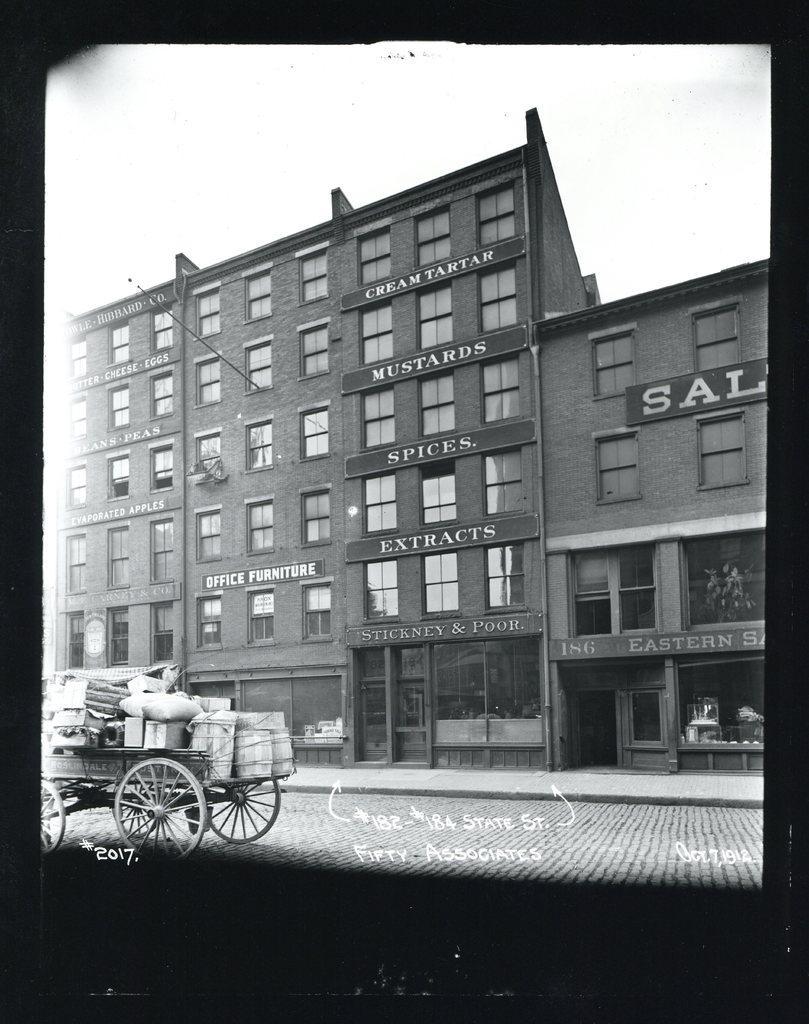Please provide a concise description of this image. In this image I think it is photo. There is road. There is a cart with luggage on the left side. There are buildings. 